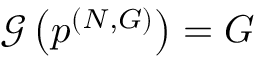Convert formula to latex. <formula><loc_0><loc_0><loc_500><loc_500>\mathcal { G } \left ( p ^ { ( N , G ) } \right ) = G</formula> 